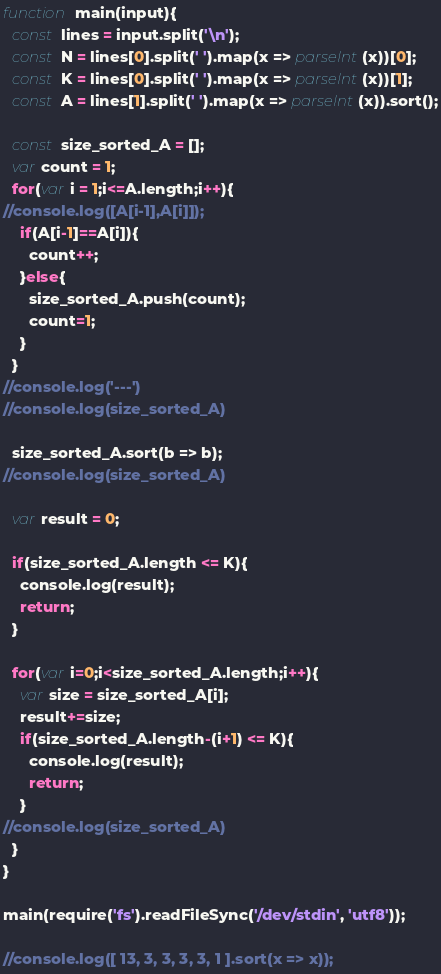Convert code to text. <code><loc_0><loc_0><loc_500><loc_500><_JavaScript_>function main(input){
  const lines = input.split('\n');
  const N = lines[0].split(' ').map(x => parseInt(x))[0];
  const K = lines[0].split(' ').map(x => parseInt(x))[1];
  const A = lines[1].split(' ').map(x => parseInt(x)).sort();

  const size_sorted_A = [];
  var count = 1;
  for(var i = 1;i<=A.length;i++){
//console.log([A[i-1],A[i]]);
    if(A[i-1]==A[i]){
      count++;
    }else{
      size_sorted_A.push(count);
      count=1;
    }
  }
//console.log('---')
//console.log(size_sorted_A)

  size_sorted_A.sort(b => b);
//console.log(size_sorted_A)

  var result = 0;

  if(size_sorted_A.length <= K){
    console.log(result);
    return;
  }

  for(var i=0;i<size_sorted_A.length;i++){
    var size = size_sorted_A[i];
    result+=size;
    if(size_sorted_A.length-(i+1) <= K){
      console.log(result);
      return;
    }
//console.log(size_sorted_A)
  }
}

main(require('fs').readFileSync('/dev/stdin', 'utf8'));

//console.log([ 13, 3, 3, 3, 3, 1 ].sort(x => x));
</code> 